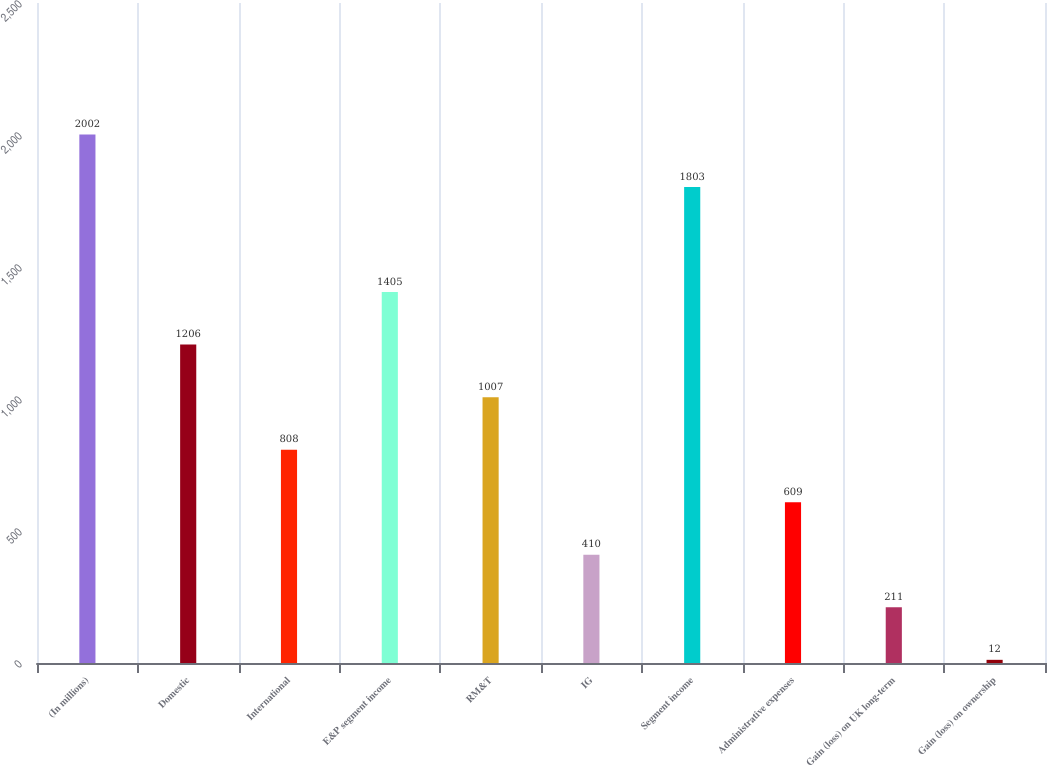Convert chart to OTSL. <chart><loc_0><loc_0><loc_500><loc_500><bar_chart><fcel>(In millions)<fcel>Domestic<fcel>International<fcel>E&P segment income<fcel>RM&T<fcel>IG<fcel>Segment income<fcel>Administrative expenses<fcel>Gain (loss) on UK long-term<fcel>Gain (loss) on ownership<nl><fcel>2002<fcel>1206<fcel>808<fcel>1405<fcel>1007<fcel>410<fcel>1803<fcel>609<fcel>211<fcel>12<nl></chart> 